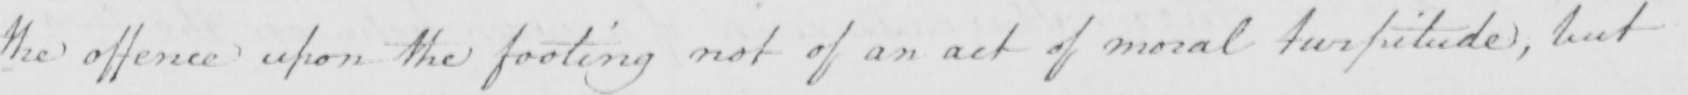What does this handwritten line say? the offence upon the footing not of an act of moral turpitude , but 